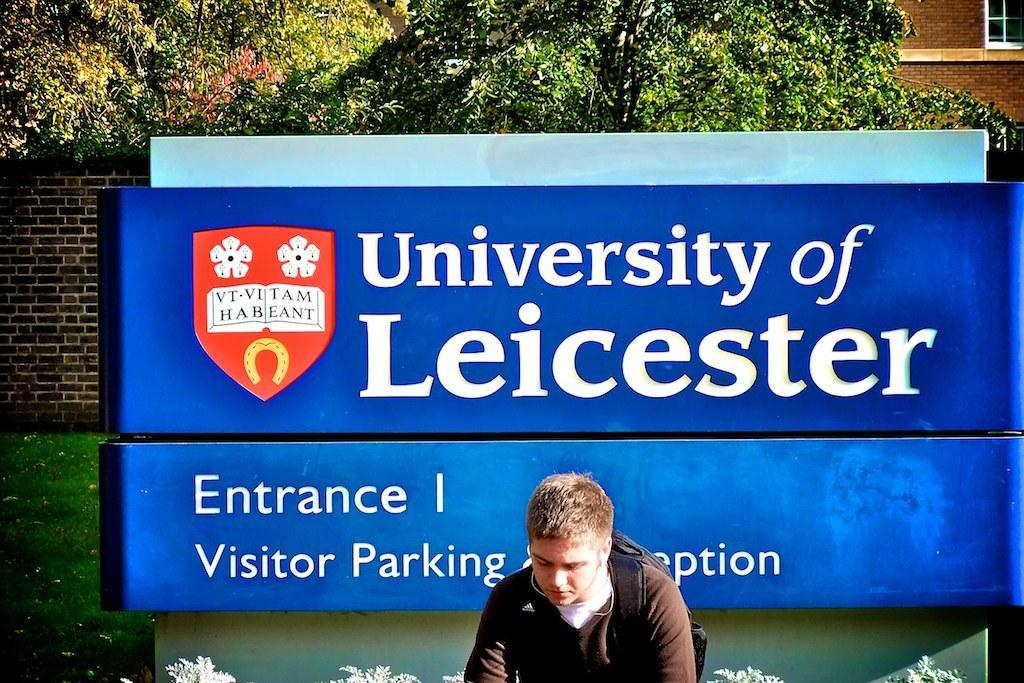<image>
Offer a succinct explanation of the picture presented. A young man sits in front of a sign for the University of Leicester's parking entrance. 